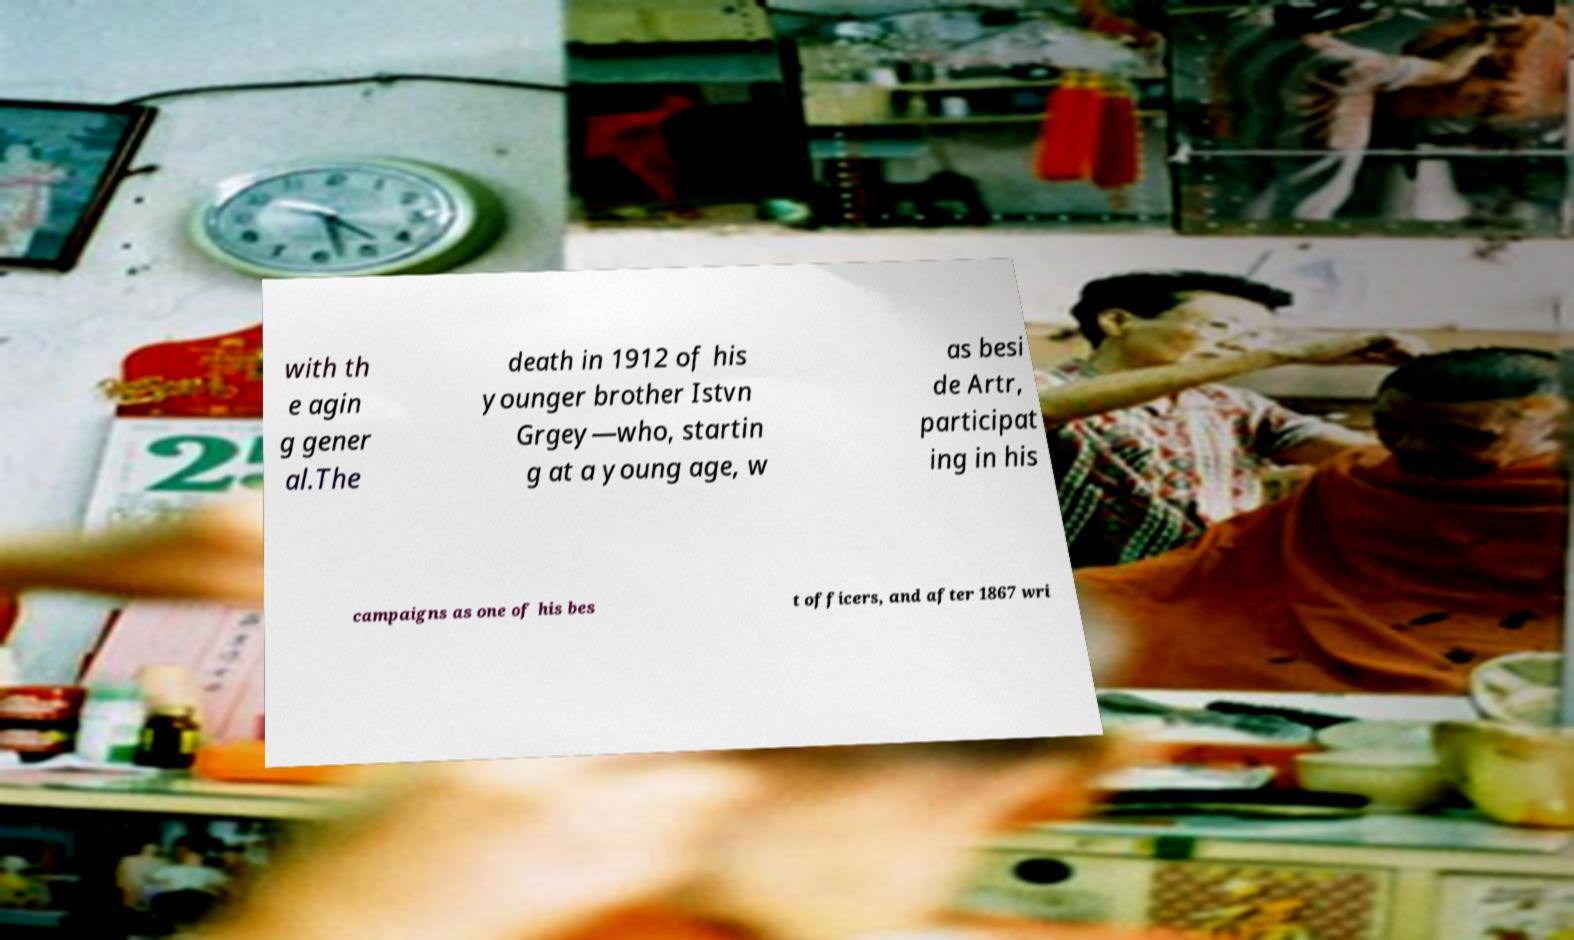What messages or text are displayed in this image? I need them in a readable, typed format. with th e agin g gener al.The death in 1912 of his younger brother Istvn Grgey—who, startin g at a young age, w as besi de Artr, participat ing in his campaigns as one of his bes t officers, and after 1867 wri 